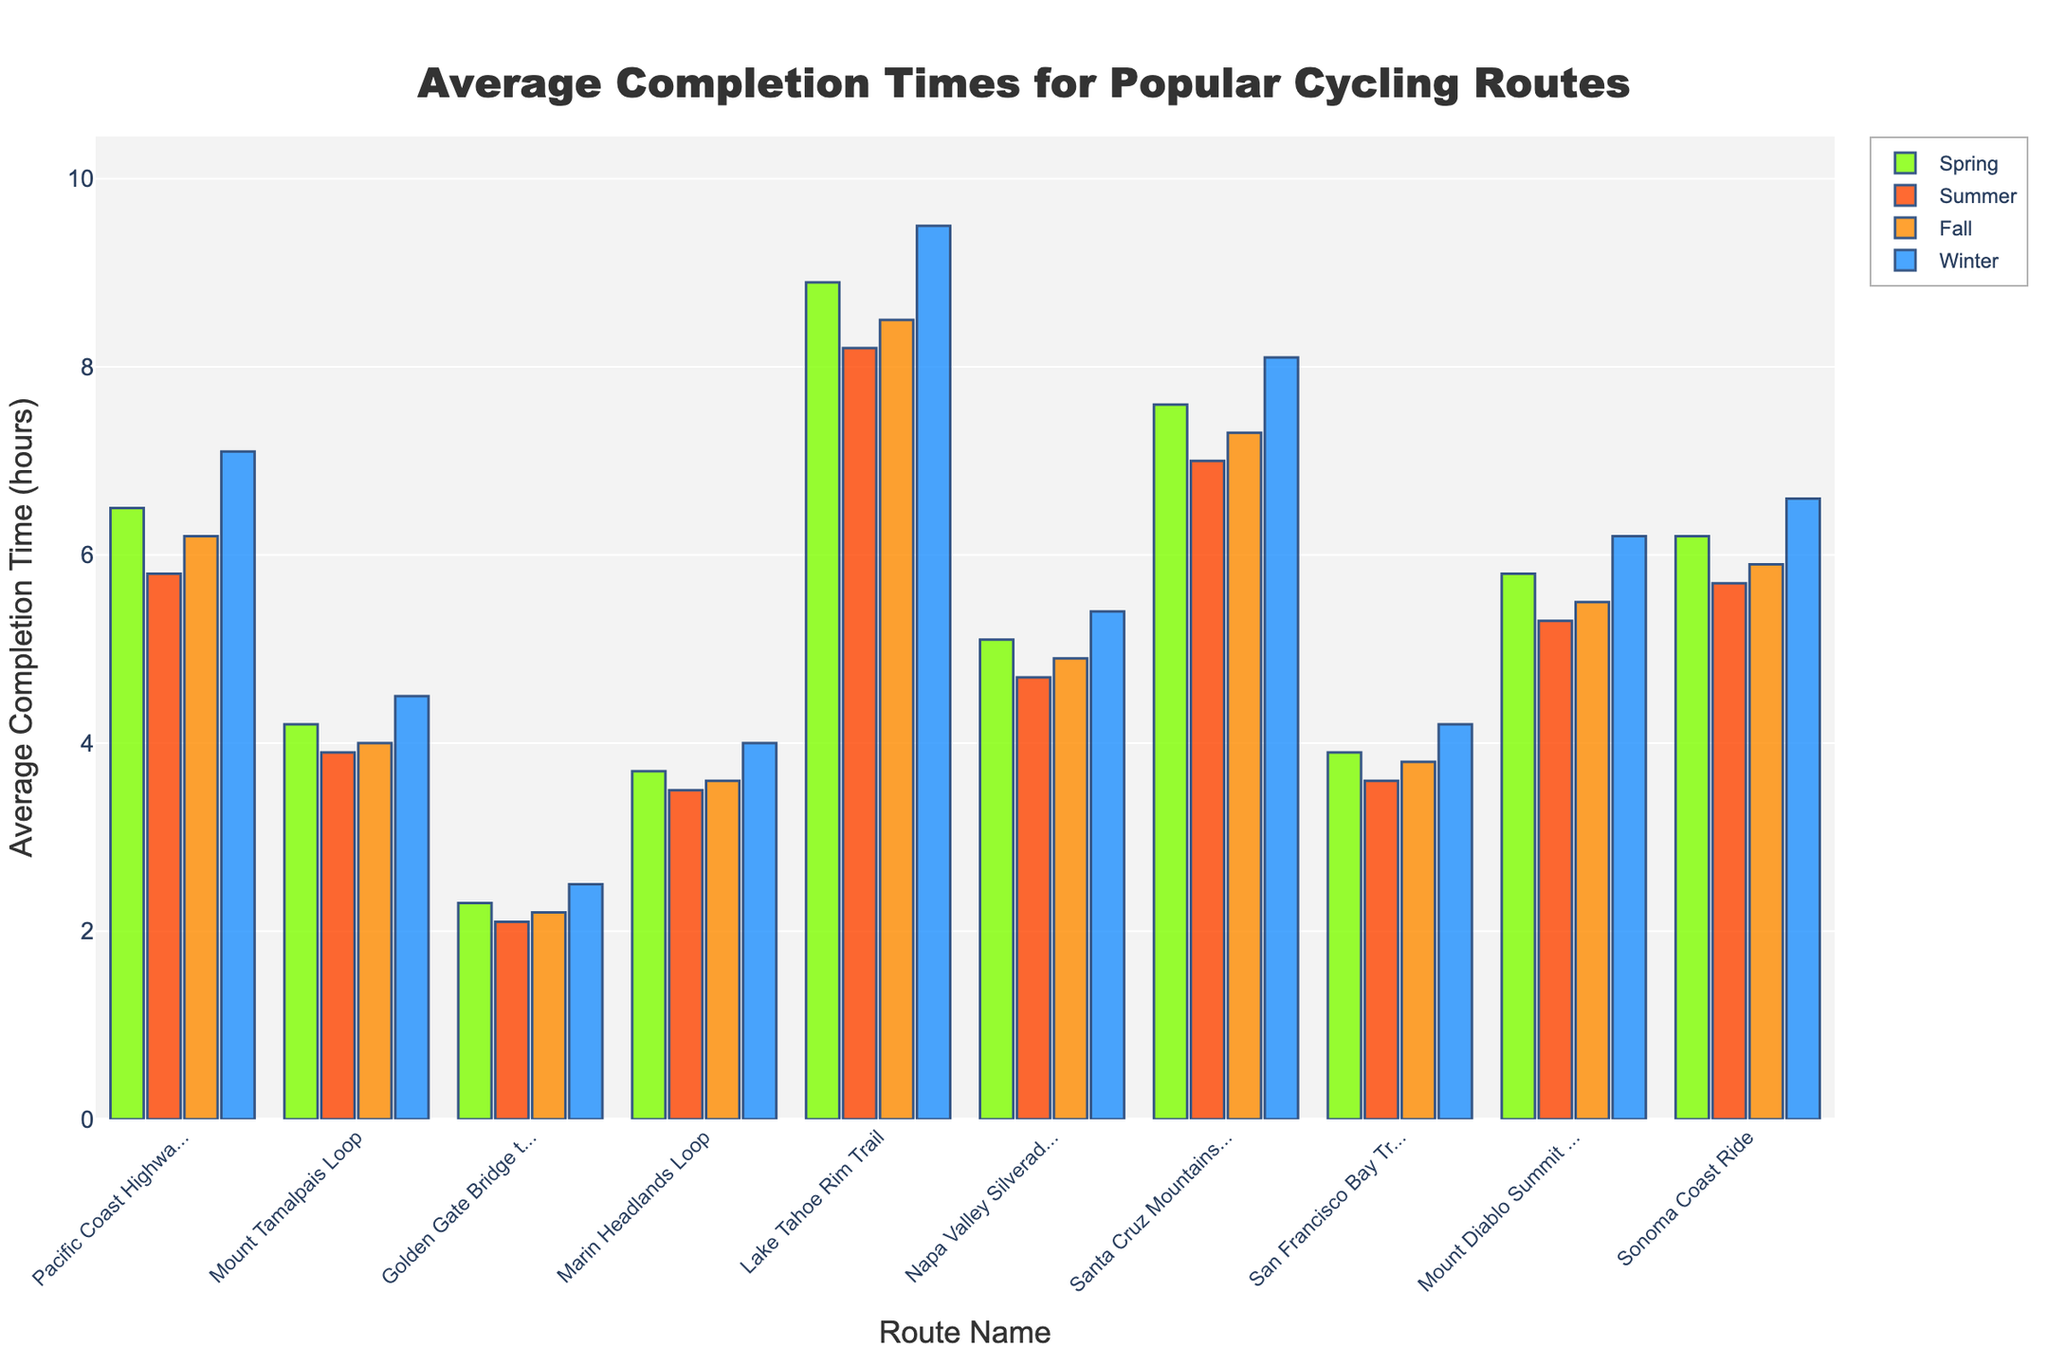What's the average completion time for the Golden Gate Bridge to Sausalito route across all seasons? Add the times for each season (2.3 + 2.1 + 2.2 + 2.5) = 9.1, then divide by the number of seasons (4). 9.1 / 4 = 2.275 hours
Answer: 2.275 hours Which route has the longest average completion time in summer? The bar for Lake Tahoe Rim Trail in summer is the longest among all summer bars, indicating it has the highest average completion time in summer (8.2 hours)
Answer: Lake Tahoe Rim Trail What is the difference in completion time for the Mount Diablo Summit Ride between winter and summer? The completion time in winter is 6.2 hours and in summer 5.3 hours. Subtract the summer time from the winter time: 6.2 - 5.3 = 0.9
Answer: 0.9 hours Which season has the shortest average completion times for most routes? The bars for Summer are generally shorter across most routes in comparison to Spring, Fall, and Winter, indicating that Summer has the shortest average completion times
Answer: Summer How much longer is the average completion time for the Santa Cruz Mountains Challenge in winter compared to fall? The completion time in winter is 8.1 hours and in fall 7.3 hours. Subtract the fall time from the winter time: 8.1 - 7.3 = 0.8
Answer: 0.8 hours Which route has the smallest variation in completion time across all seasons? Compare the height differences of bars for each season per route. The Golden Gate Bridge to Sausalito route shows the smallest difference, with times ranging only from 2.1 to 2.5 hours
Answer: Golden Gate Bridge to Sausalito Out of all the routes, which one has the highest average completion time in winter? The Lake Tahoe Rim Trail has the tallest bar in the winter season, indicating it has the highest completion time of 9.5 hours
Answer: Lake Tahoe Rim Trail Which routes have a completion time greater than 7 hours in both spring and winter? Check routes with bars above 7 in both spring and winter: Lake Tahoe Rim Trail (8.9 in spring, 9.5 in winter) and Santa Cruz Mountains Challenge (7.6 in spring, 8.1 in winter)
Answer: Lake Tahoe Rim Trail, Santa Cruz Mountains Challenge 